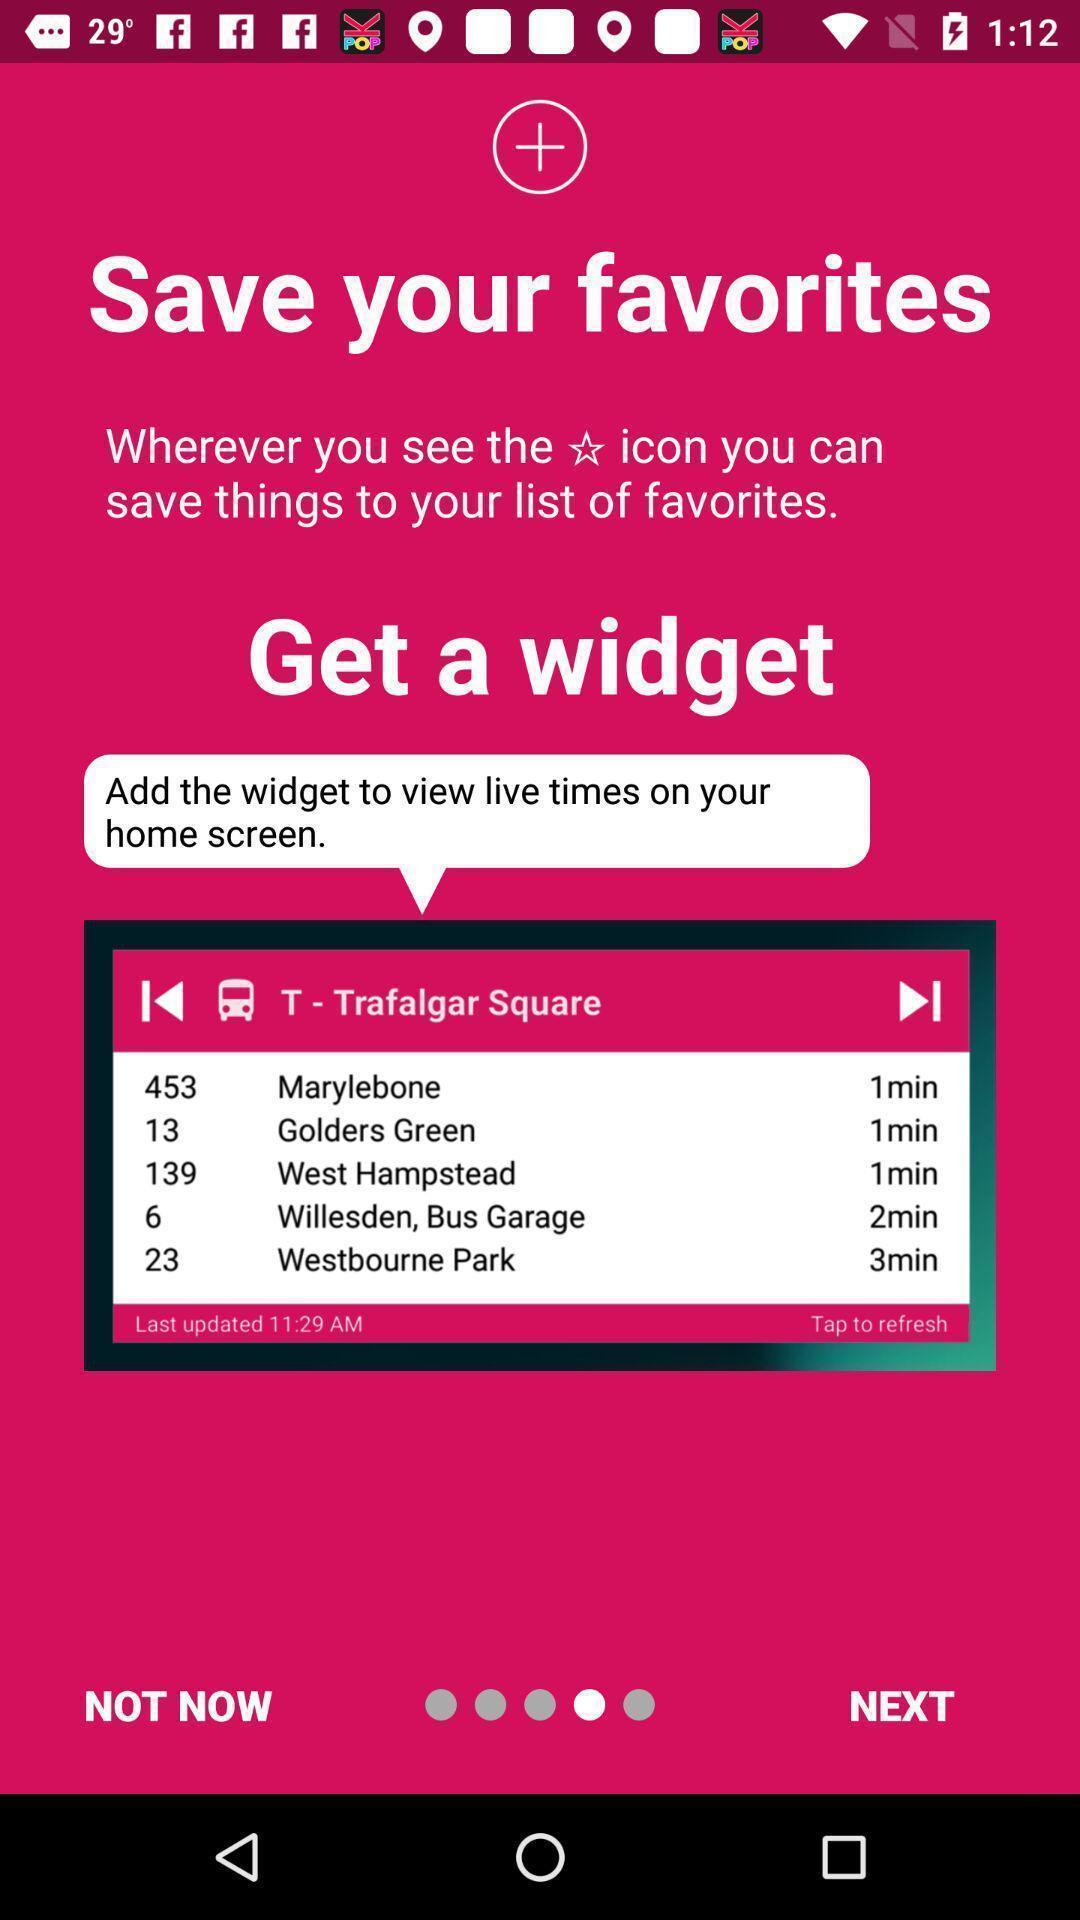Provide a description of this screenshot. Widgets asking to save list of favorites. 